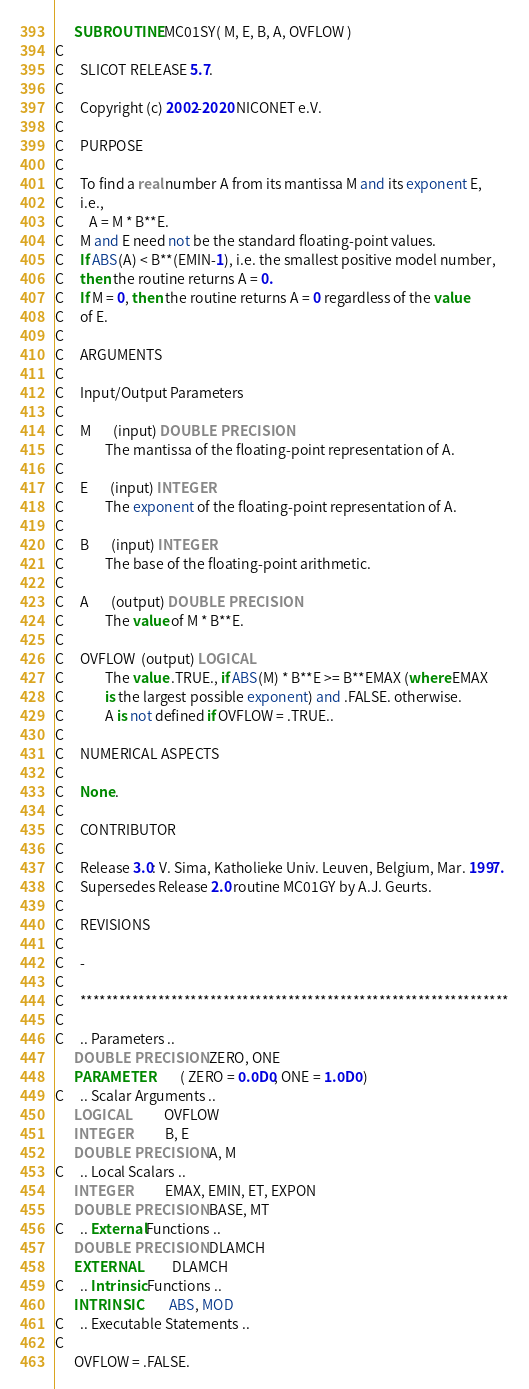Convert code to text. <code><loc_0><loc_0><loc_500><loc_500><_FORTRAN_>      SUBROUTINE MC01SY( M, E, B, A, OVFLOW )
C
C     SLICOT RELEASE 5.7.
C
C     Copyright (c) 2002-2020 NICONET e.V.
C
C     PURPOSE
C
C     To find a real number A from its mantissa M and its exponent E,
C     i.e.,
C        A = M * B**E.
C     M and E need not be the standard floating-point values.
C     If ABS(A) < B**(EMIN-1), i.e. the smallest positive model number,
C     then the routine returns A = 0.
C     If M = 0, then the routine returns A = 0 regardless of the value
C     of E.
C
C     ARGUMENTS
C
C     Input/Output Parameters
C
C     M       (input) DOUBLE PRECISION
C             The mantissa of the floating-point representation of A.
C
C     E       (input) INTEGER
C             The exponent of the floating-point representation of A.
C
C     B       (input) INTEGER
C             The base of the floating-point arithmetic.
C
C     A       (output) DOUBLE PRECISION
C             The value of M * B**E.
C
C     OVFLOW  (output) LOGICAL
C             The value .TRUE., if ABS(M) * B**E >= B**EMAX (where EMAX
C             is the largest possible exponent) and .FALSE. otherwise.
C             A is not defined if OVFLOW = .TRUE..
C
C     NUMERICAL ASPECTS
C
C     None.
C
C     CONTRIBUTOR
C
C     Release 3.0: V. Sima, Katholieke Univ. Leuven, Belgium, Mar. 1997.
C     Supersedes Release 2.0 routine MC01GY by A.J. Geurts.
C
C     REVISIONS
C
C     -
C
C     ******************************************************************
C
C     .. Parameters ..
      DOUBLE PRECISION  ZERO, ONE
      PARAMETER         ( ZERO = 0.0D0, ONE = 1.0D0 )
C     .. Scalar Arguments ..
      LOGICAL           OVFLOW
      INTEGER           B, E
      DOUBLE PRECISION  A, M
C     .. Local Scalars ..
      INTEGER           EMAX, EMIN, ET, EXPON
      DOUBLE PRECISION  BASE, MT
C     .. External Functions ..
      DOUBLE PRECISION  DLAMCH
      EXTERNAL          DLAMCH
C     .. Intrinsic Functions ..
      INTRINSIC         ABS, MOD
C     .. Executable Statements ..
C
      OVFLOW = .FALSE.</code> 